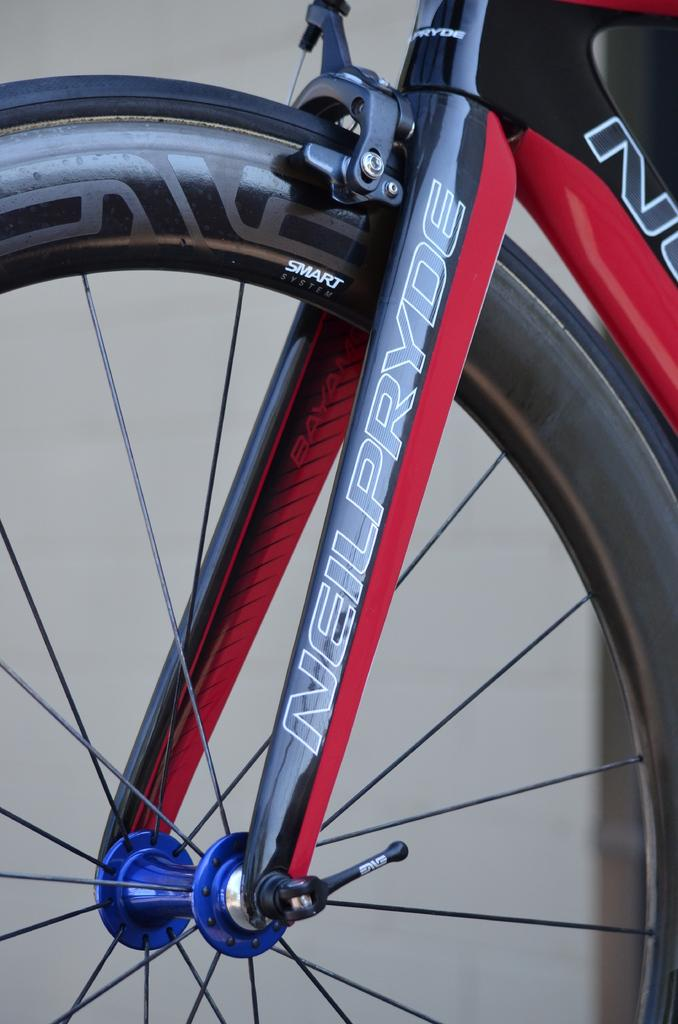What type of vehicle is depicted in the image? The image features a truncated bicycle. Which part of the bicycle is visible in the image? A bicycle wheel is visible in the image. Can you describe the background of the image? The background of the image is blurred. What type of laborer is working on the attraction in the image? There is no laborer or attraction present in the image; it features a truncated bicycle and a blurred background. 